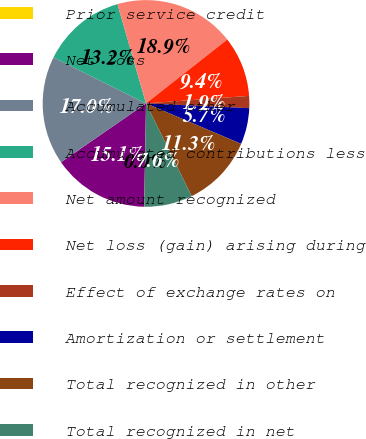<chart> <loc_0><loc_0><loc_500><loc_500><pie_chart><fcel>Prior service credit<fcel>Net loss<fcel>Accumulated other<fcel>Accumulated contributions less<fcel>Net amount recognized<fcel>Net loss (gain) arising during<fcel>Effect of exchange rates on<fcel>Amortization or settlement<fcel>Total recognized in other<fcel>Total recognized in net<nl><fcel>0.02%<fcel>15.08%<fcel>16.97%<fcel>13.2%<fcel>18.85%<fcel>9.44%<fcel>1.9%<fcel>5.67%<fcel>11.32%<fcel>7.55%<nl></chart> 